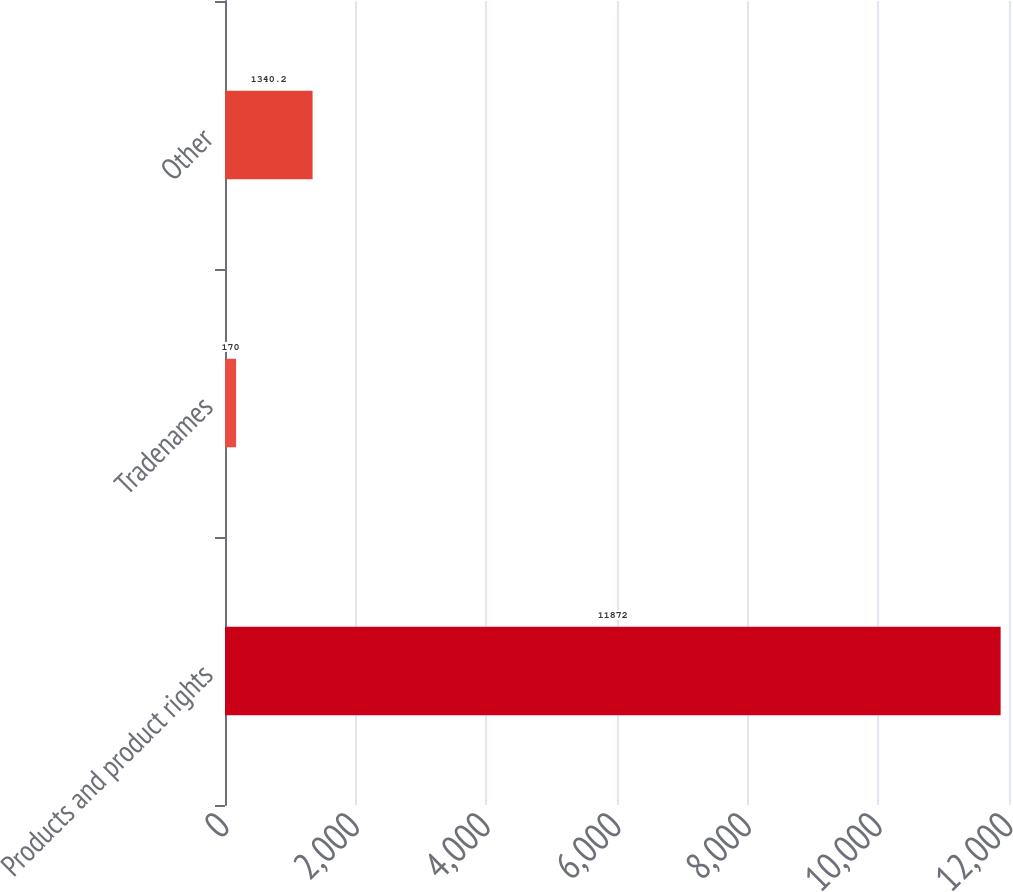Convert chart. <chart><loc_0><loc_0><loc_500><loc_500><bar_chart><fcel>Products and product rights<fcel>Tradenames<fcel>Other<nl><fcel>11872<fcel>170<fcel>1340.2<nl></chart> 